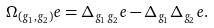<formula> <loc_0><loc_0><loc_500><loc_500>\Omega _ { ( g _ { 1 } , g _ { 2 } ) } e = \Delta _ { g _ { 1 } g _ { 2 } } e - \Delta _ { g _ { 1 } } \Delta _ { g _ { 2 } } e .</formula> 